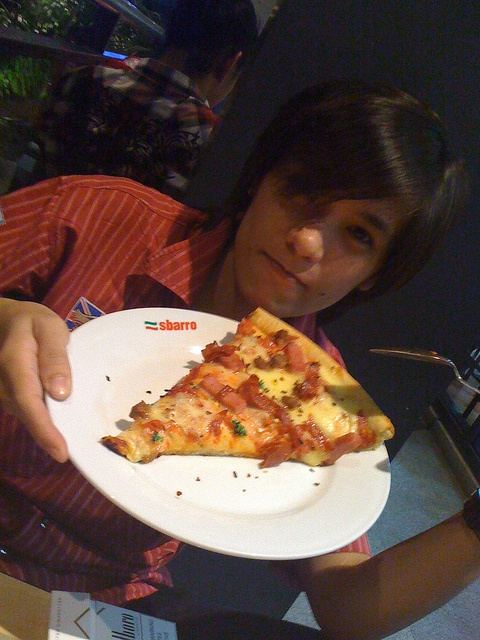Describe the objects in this image and their specific colors. I can see people in black, maroon, and brown tones, people in black, maroon, and gray tones, pizza in black, orange, brown, and red tones, and fork in black, maroon, and gray tones in this image. 